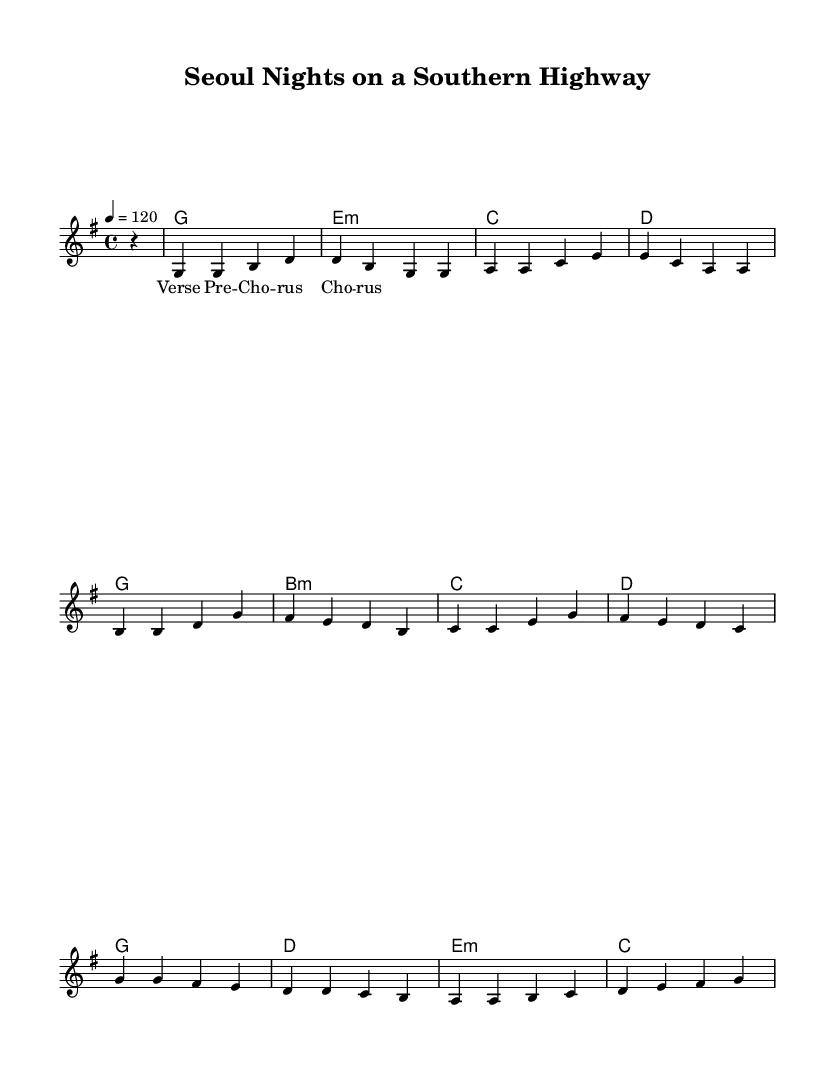What is the key signature of this music? The key signature is G major, which has one sharp (F#). This is identifiable by the key signature on the staff before the music begins.
Answer: G major What is the time signature of this music? The time signature is 4/4, meaning there are four beats per measure and the quarter note gets one beat. This can be determined from the time signature notation displayed at the beginning of the score.
Answer: 4/4 What is the tempo marking? The tempo marking is 120 beats per minute. This is indicated right after the time signature in the global settings.
Answer: 120 How many measures are in the verse section? The verse section contains four measures based on the melody notation provided. By counting the grouped sets of rhythm symbols, we can assess that the verse has a total of four measures.
Answer: Four Which section has a minor chord as the first harmony? The verse section features an E minor chord as the first harmony. By analyzing the harmonic progression written below the melody, we can identify the first chord in the verse as E minor.
Answer: E minor What melodic pattern does the pre-chorus start with? The pre-chorus starts with the note B, following the rhythmic pattern illustrated in the melody section. This can be recognized by looking at the first note of the pre-chorus melody line.
Answer: B What does the chorus predominantly feature in its melody? The chorus predominantly features the notes G, A, and B. This can be noted by examining the melody line in the chorus section, where these notes are repeated throughout its bars.
Answer: G, A, B 